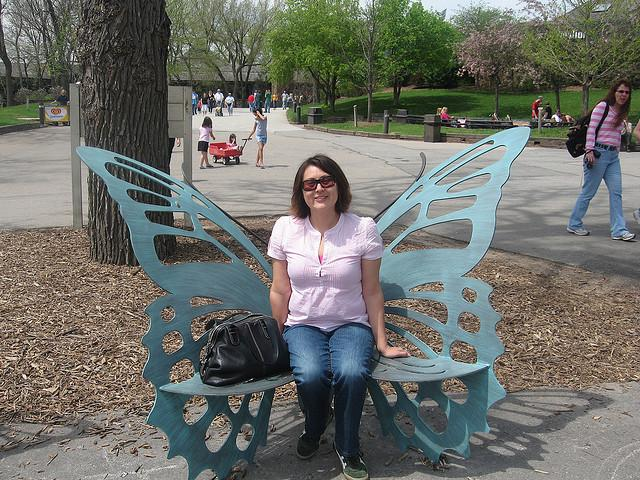What is the process that produces the type of animal depicted on the bench called? metamorphosis 